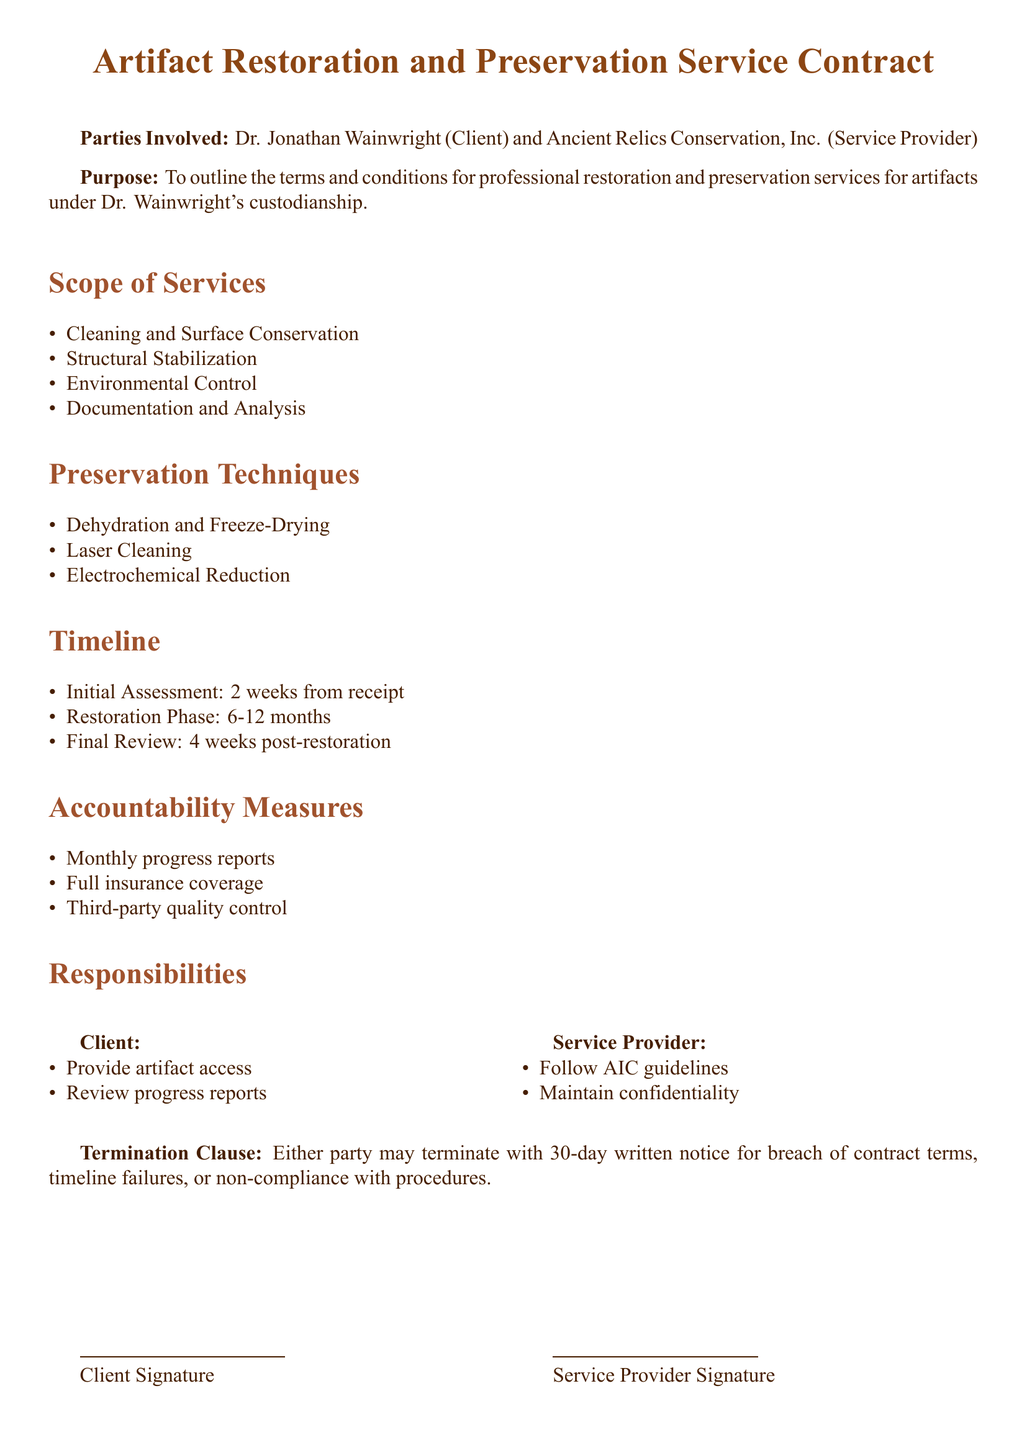What is the client's name? The client's name is explicitly stated at the beginning of the document under "Parties Involved."
Answer: Dr. Jonathan Wainwright How many weeks for the initial assessment? The timeline section specifies the duration for the initial assessment.
Answer: 2 weeks What preservation technique involves laser technology? The preservation techniques are listed, and one of them involves the use of laser technology.
Answer: Laser Cleaning What is the duration of the restoration phase? The document states the timeline for the restoration phase varies between two specific limits.
Answer: 6-12 months What is the termination notice period? The termination clause specifies the required notice period for termination of the contract.
Answer: 30-day Who is responsible for following AIC guidelines? The responsibilities section indicates which party is required to follow these specific guidelines.
Answer: Service Provider How often are progress reports required? The accountability measures section states the frequency of the progress reports.
Answer: Monthly What type of coverage is assured for the artifacts? The accountability measures section mentions a specific type of risk assurance.
Answer: Full insurance coverage 